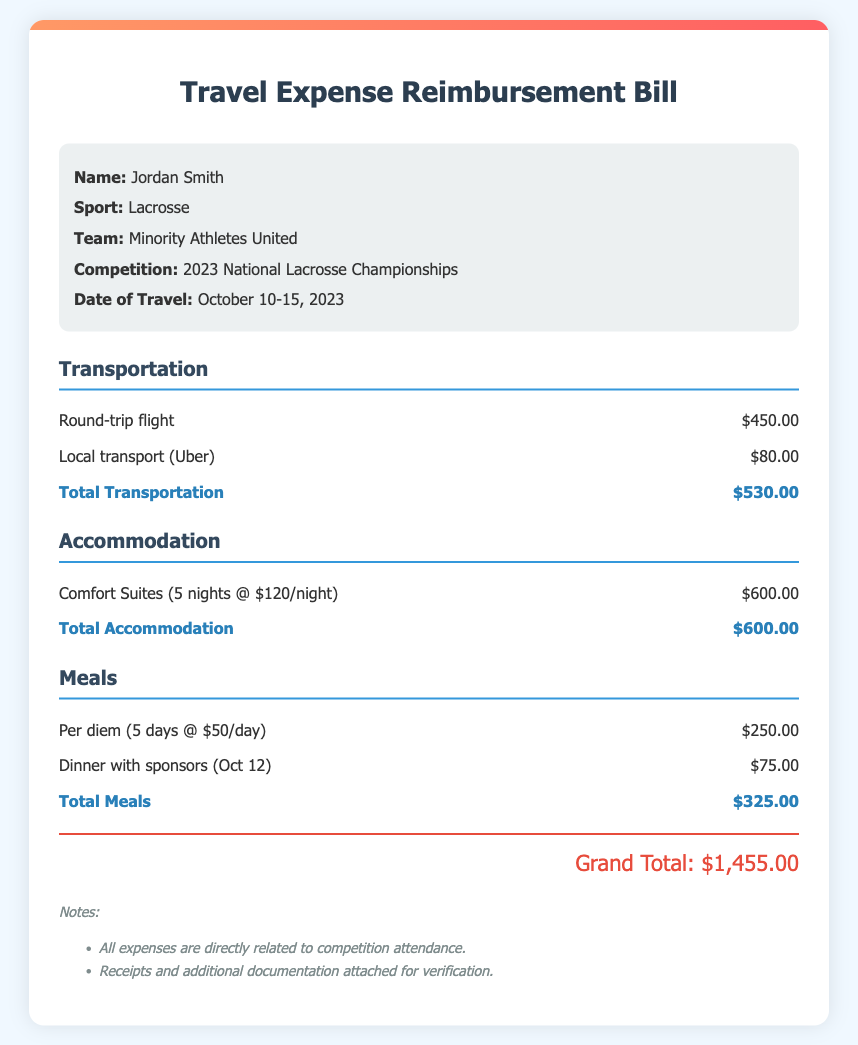What is the athlete's name? The document states the athlete's name at the beginning, which is Jordan Smith.
Answer: Jordan Smith What sport does the athlete compete in? The sport is mentioned in the athlete information section as Lacrosse.
Answer: Lacrosse What is the total amount for transportation expenses? The total for transportation is calculated from the details provided, which amounts to $530.00.
Answer: $530.00 How many nights did the athlete stay at the hotel? The accommodation section specifies the stay as 5 nights in total.
Answer: 5 nights What was the total for meals? The meal expenses add up to $325.00, as outlined in the meals section.
Answer: $325.00 What is the date range for the travel? The date range for travel is indicated in the athlete information, from October 10 to October 15, 2023.
Answer: October 10-15, 2023 What is the grand total of expenses incurred? The grand total is displayed at the bottom of the document as $1,455.00.
Answer: $1,455.00 What hotel did the athlete stay at? The accommodation section names the hotel as Comfort Suites.
Answer: Comfort Suites What percentage of the total expenses are from transportation? The transportation total is $530.00, which is a part of the grand total of $1,455.00, leading to a calculation for the percentage: (530/1455) * 100.
Answer: Approximately 36.4% 